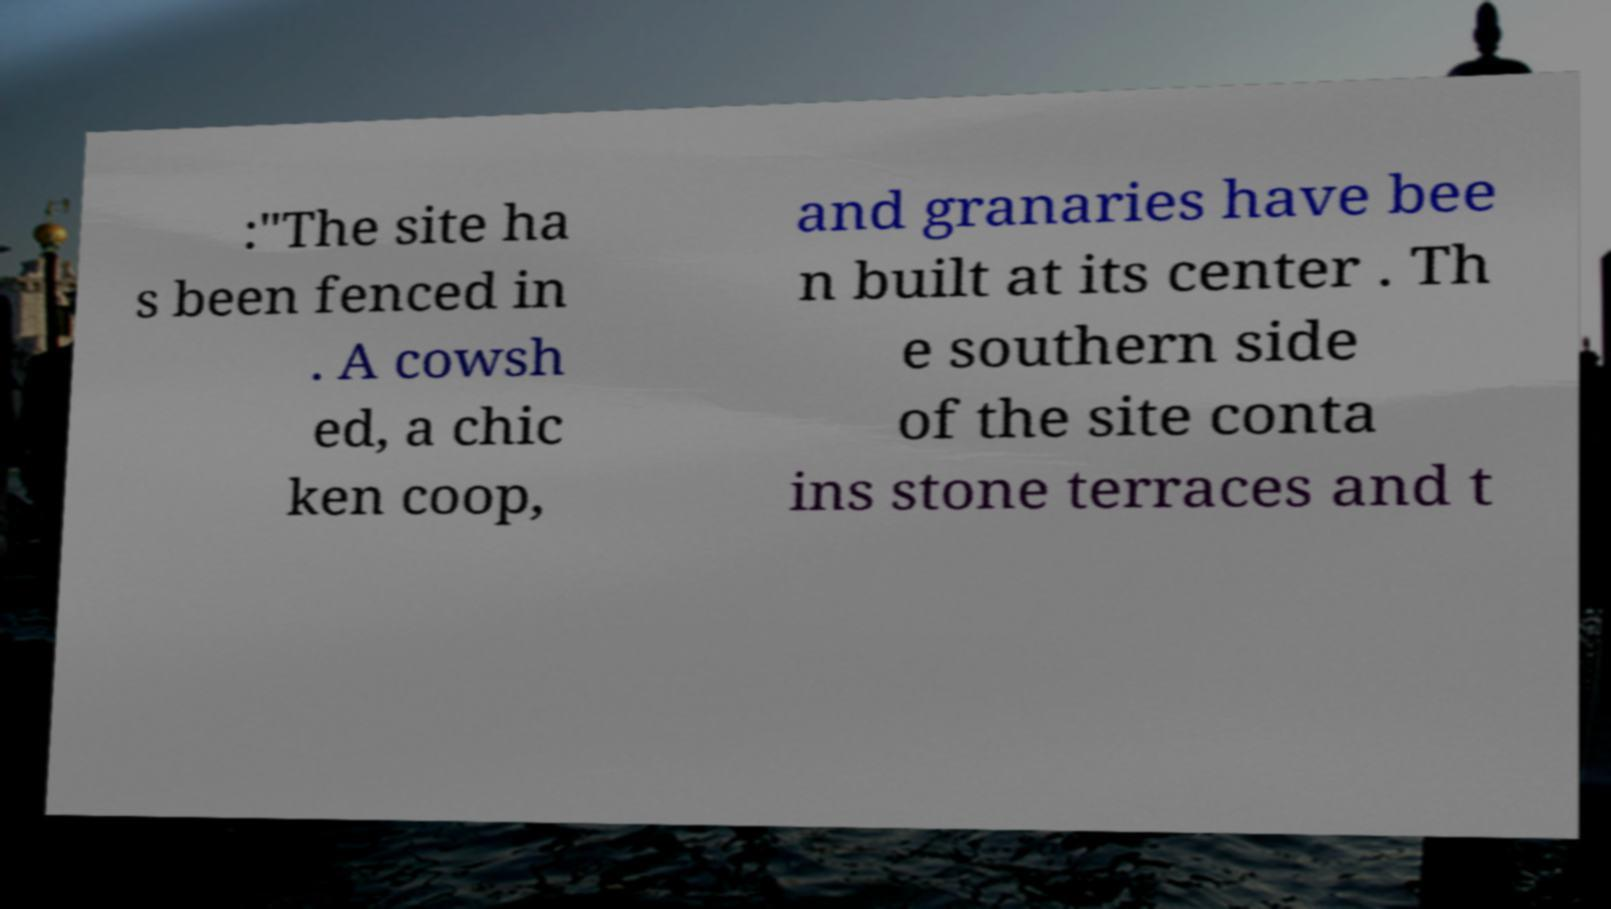For documentation purposes, I need the text within this image transcribed. Could you provide that? :"The site ha s been fenced in . A cowsh ed, a chic ken coop, and granaries have bee n built at its center . Th e southern side of the site conta ins stone terraces and t 